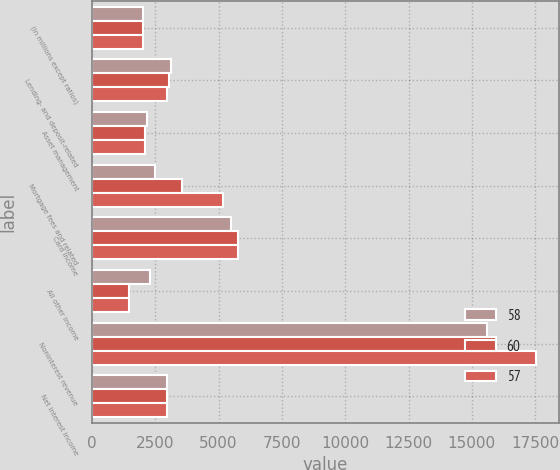<chart> <loc_0><loc_0><loc_500><loc_500><stacked_bar_chart><ecel><fcel>(in millions except ratios)<fcel>Lending- and deposit-related<fcel>Asset management<fcel>Mortgage fees and related<fcel>Card income<fcel>All other income<fcel>Noninterest revenue<fcel>Net interest income<nl><fcel>58<fcel>2015<fcel>3137<fcel>2172<fcel>2511<fcel>5491<fcel>2281<fcel>15592<fcel>2983<nl><fcel>60<fcel>2014<fcel>3039<fcel>2096<fcel>3560<fcel>5779<fcel>1463<fcel>15937<fcel>2983<nl><fcel>57<fcel>2013<fcel>2983<fcel>2116<fcel>5195<fcel>5785<fcel>1473<fcel>17552<fcel>2983<nl></chart> 